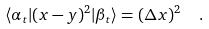<formula> <loc_0><loc_0><loc_500><loc_500>\langle \alpha _ { t } | ( x - y ) ^ { 2 } | \beta _ { t } \rangle = ( \Delta x ) ^ { 2 } \ \ .</formula> 